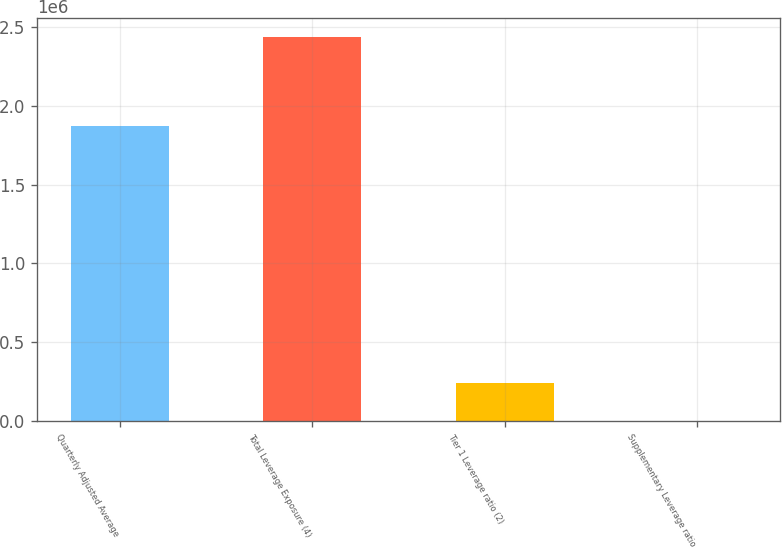Convert chart to OTSL. <chart><loc_0><loc_0><loc_500><loc_500><bar_chart><fcel>Quarterly Adjusted Average<fcel>Total Leverage Exposure (4)<fcel>Tier 1 Leverage ratio (2)<fcel>Supplementary Leverage ratio<nl><fcel>1.86833e+06<fcel>2.43249e+06<fcel>243255<fcel>6.68<nl></chart> 